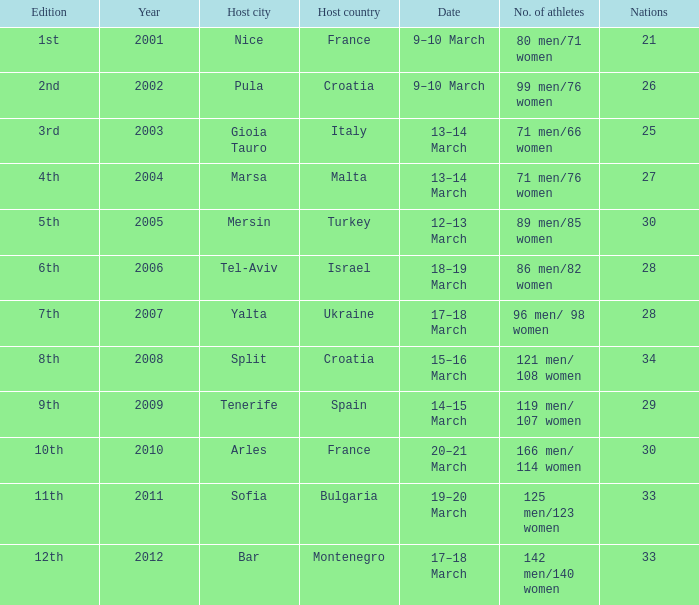What was the last year? 2012.0. 